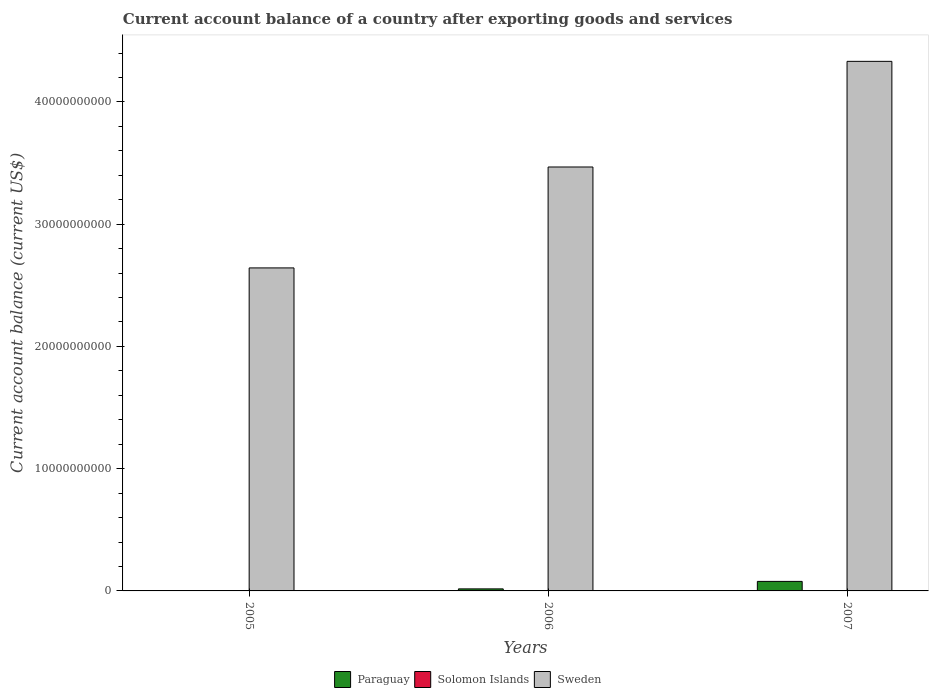How many different coloured bars are there?
Provide a succinct answer. 2. Are the number of bars per tick equal to the number of legend labels?
Keep it short and to the point. No. How many bars are there on the 2nd tick from the left?
Your answer should be very brief. 2. What is the label of the 2nd group of bars from the left?
Make the answer very short. 2006. In how many cases, is the number of bars for a given year not equal to the number of legend labels?
Provide a short and direct response. 3. What is the account balance in Paraguay in 2005?
Make the answer very short. 0. Across all years, what is the maximum account balance in Sweden?
Keep it short and to the point. 4.33e+1. What is the total account balance in Paraguay in the graph?
Keep it short and to the point. 9.46e+08. What is the difference between the account balance in Sweden in 2005 and that in 2007?
Your response must be concise. -1.69e+1. What is the difference between the account balance in Sweden in 2007 and the account balance in Paraguay in 2006?
Offer a very short reply. 4.32e+1. What is the average account balance in Sweden per year?
Your answer should be very brief. 3.48e+1. In the year 2007, what is the difference between the account balance in Paraguay and account balance in Sweden?
Offer a terse response. -4.25e+1. What is the ratio of the account balance in Sweden in 2005 to that in 2006?
Make the answer very short. 0.76. Is the difference between the account balance in Paraguay in 2006 and 2007 greater than the difference between the account balance in Sweden in 2006 and 2007?
Your answer should be very brief. Yes. What is the difference between the highest and the second highest account balance in Sweden?
Your answer should be very brief. 8.64e+09. What is the difference between the highest and the lowest account balance in Sweden?
Provide a short and direct response. 1.69e+1. In how many years, is the account balance in Paraguay greater than the average account balance in Paraguay taken over all years?
Ensure brevity in your answer.  1. Is it the case that in every year, the sum of the account balance in Solomon Islands and account balance in Paraguay is greater than the account balance in Sweden?
Make the answer very short. No. How many bars are there?
Ensure brevity in your answer.  5. How many years are there in the graph?
Your answer should be compact. 3. Are the values on the major ticks of Y-axis written in scientific E-notation?
Provide a short and direct response. No. Does the graph contain grids?
Provide a succinct answer. No. Where does the legend appear in the graph?
Make the answer very short. Bottom center. What is the title of the graph?
Your answer should be compact. Current account balance of a country after exporting goods and services. Does "West Bank and Gaza" appear as one of the legend labels in the graph?
Provide a succinct answer. No. What is the label or title of the X-axis?
Make the answer very short. Years. What is the label or title of the Y-axis?
Offer a terse response. Current account balance (current US$). What is the Current account balance (current US$) of Paraguay in 2005?
Your answer should be very brief. 0. What is the Current account balance (current US$) in Solomon Islands in 2005?
Provide a succinct answer. 0. What is the Current account balance (current US$) of Sweden in 2005?
Offer a terse response. 2.64e+1. What is the Current account balance (current US$) of Paraguay in 2006?
Make the answer very short. 1.67e+08. What is the Current account balance (current US$) in Sweden in 2006?
Give a very brief answer. 3.47e+1. What is the Current account balance (current US$) in Paraguay in 2007?
Offer a terse response. 7.79e+08. What is the Current account balance (current US$) of Solomon Islands in 2007?
Ensure brevity in your answer.  0. What is the Current account balance (current US$) of Sweden in 2007?
Give a very brief answer. 4.33e+1. Across all years, what is the maximum Current account balance (current US$) of Paraguay?
Your answer should be very brief. 7.79e+08. Across all years, what is the maximum Current account balance (current US$) of Sweden?
Your answer should be compact. 4.33e+1. Across all years, what is the minimum Current account balance (current US$) in Sweden?
Your answer should be compact. 2.64e+1. What is the total Current account balance (current US$) in Paraguay in the graph?
Offer a terse response. 9.46e+08. What is the total Current account balance (current US$) of Solomon Islands in the graph?
Offer a terse response. 0. What is the total Current account balance (current US$) in Sweden in the graph?
Offer a terse response. 1.04e+11. What is the difference between the Current account balance (current US$) of Sweden in 2005 and that in 2006?
Give a very brief answer. -8.25e+09. What is the difference between the Current account balance (current US$) in Sweden in 2005 and that in 2007?
Provide a short and direct response. -1.69e+1. What is the difference between the Current account balance (current US$) of Paraguay in 2006 and that in 2007?
Ensure brevity in your answer.  -6.12e+08. What is the difference between the Current account balance (current US$) of Sweden in 2006 and that in 2007?
Make the answer very short. -8.64e+09. What is the difference between the Current account balance (current US$) of Paraguay in 2006 and the Current account balance (current US$) of Sweden in 2007?
Keep it short and to the point. -4.32e+1. What is the average Current account balance (current US$) of Paraguay per year?
Offer a terse response. 3.15e+08. What is the average Current account balance (current US$) of Solomon Islands per year?
Make the answer very short. 0. What is the average Current account balance (current US$) of Sweden per year?
Your answer should be compact. 3.48e+1. In the year 2006, what is the difference between the Current account balance (current US$) of Paraguay and Current account balance (current US$) of Sweden?
Provide a succinct answer. -3.45e+1. In the year 2007, what is the difference between the Current account balance (current US$) of Paraguay and Current account balance (current US$) of Sweden?
Keep it short and to the point. -4.25e+1. What is the ratio of the Current account balance (current US$) of Sweden in 2005 to that in 2006?
Your answer should be compact. 0.76. What is the ratio of the Current account balance (current US$) of Sweden in 2005 to that in 2007?
Provide a short and direct response. 0.61. What is the ratio of the Current account balance (current US$) in Paraguay in 2006 to that in 2007?
Give a very brief answer. 0.21. What is the ratio of the Current account balance (current US$) in Sweden in 2006 to that in 2007?
Provide a succinct answer. 0.8. What is the difference between the highest and the second highest Current account balance (current US$) of Sweden?
Offer a terse response. 8.64e+09. What is the difference between the highest and the lowest Current account balance (current US$) in Paraguay?
Provide a succinct answer. 7.79e+08. What is the difference between the highest and the lowest Current account balance (current US$) in Sweden?
Provide a short and direct response. 1.69e+1. 